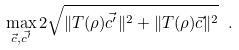<formula> <loc_0><loc_0><loc_500><loc_500>\max _ { \vec { c } , \vec { c ^ { \prime } } } 2 \sqrt { \| T ( \rho ) \vec { c ^ { \prime } } \| ^ { 2 } + \| T ( \rho ) \vec { c } \| ^ { 2 } } \ .</formula> 